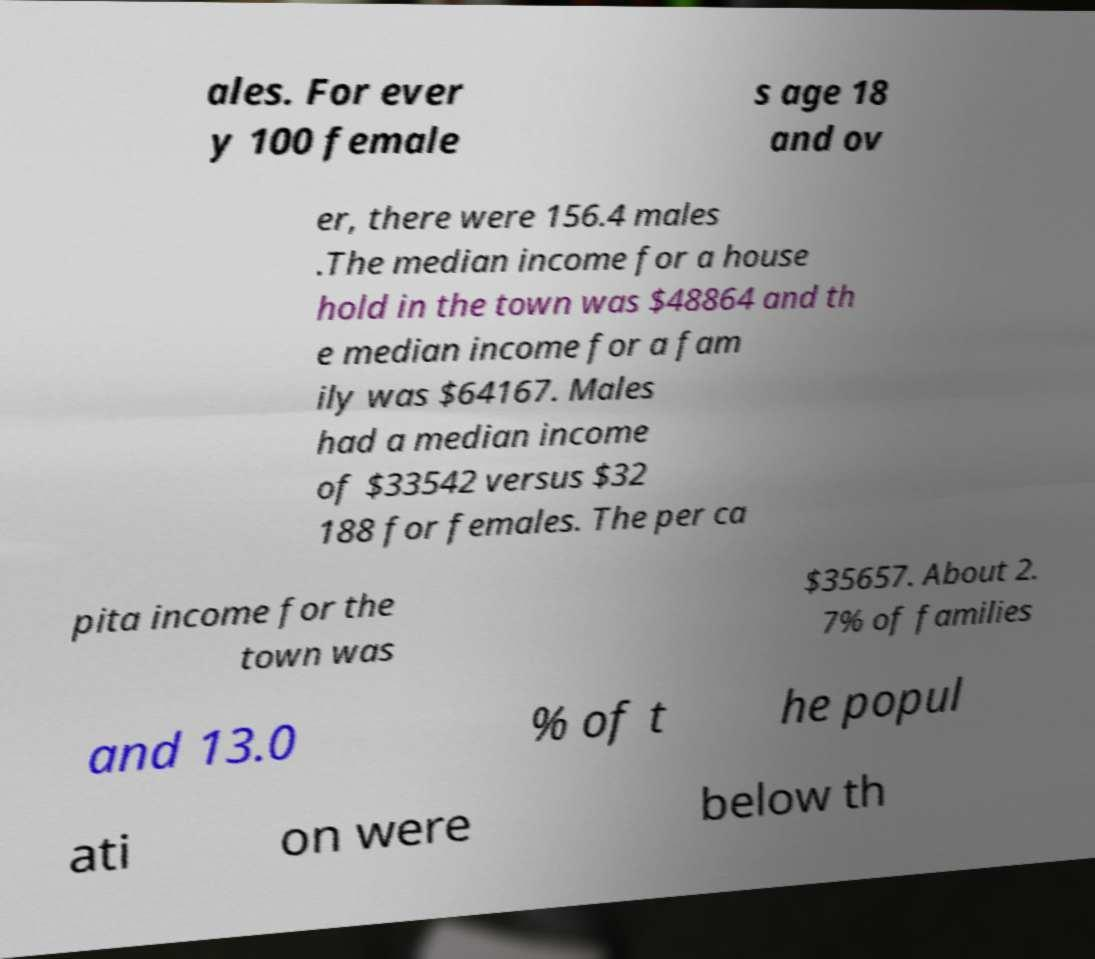Please identify and transcribe the text found in this image. ales. For ever y 100 female s age 18 and ov er, there were 156.4 males .The median income for a house hold in the town was $48864 and th e median income for a fam ily was $64167. Males had a median income of $33542 versus $32 188 for females. The per ca pita income for the town was $35657. About 2. 7% of families and 13.0 % of t he popul ati on were below th 